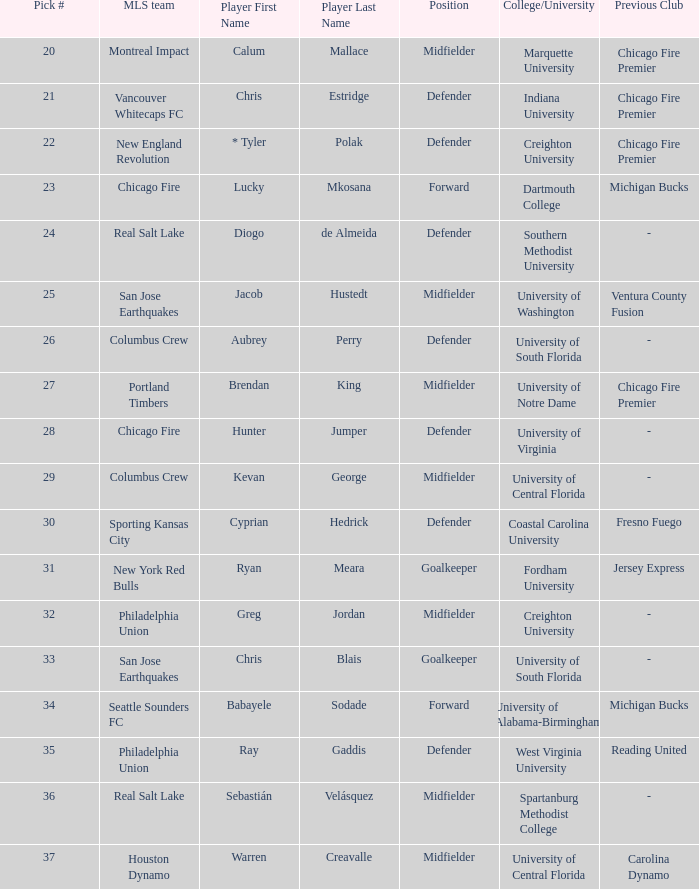Which selection number is assigned to kevan george? 29.0. 